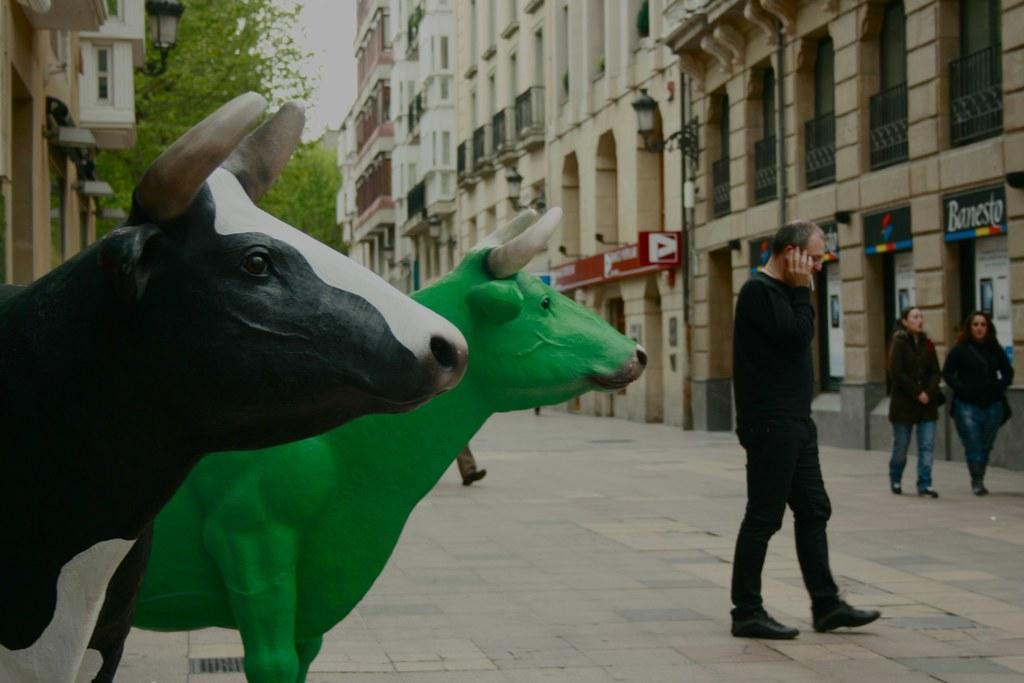What types of living organisms can be seen in the image? Animals are depicted in the image. What man-made structures are visible in the image? Buildings are visible in the image. What type of vegetation is present in the image? Trees are present in the image. What can be seen illuminating the scene in the image? Lights are visible in the image. What activity are people engaged in within the image? People are walking on a path in the image. What part of the natural environment is visible in the image? The sky is visible in the image. What type of cherry is being used as a toothbrush in the image? There is no cherry or toothbrush present in the image. How many ants are visible on the path where people are walking in the image? There are no ants visible on the path in the image. 